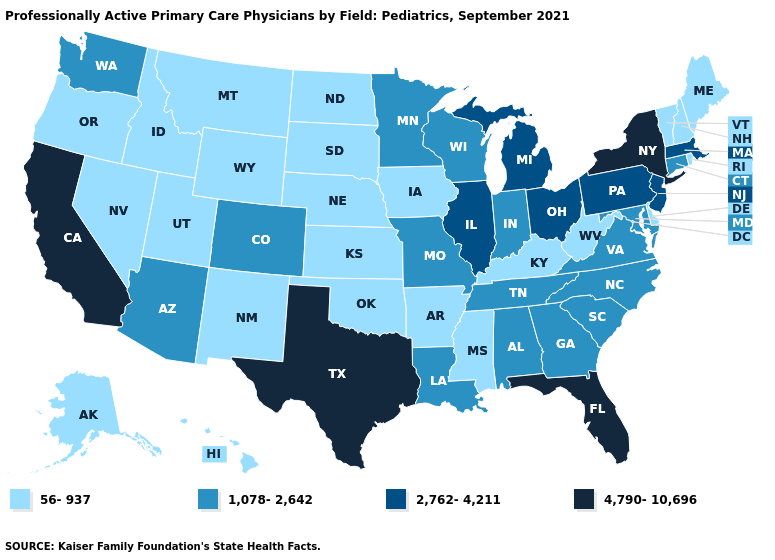What is the value of Kentucky?
Concise answer only. 56-937. How many symbols are there in the legend?
Keep it brief. 4. What is the value of Iowa?
Keep it brief. 56-937. Does Michigan have a lower value than New York?
Short answer required. Yes. What is the value of Massachusetts?
Short answer required. 2,762-4,211. What is the lowest value in the USA?
Keep it brief. 56-937. Does California have the highest value in the USA?
Short answer required. Yes. Name the states that have a value in the range 56-937?
Keep it brief. Alaska, Arkansas, Delaware, Hawaii, Idaho, Iowa, Kansas, Kentucky, Maine, Mississippi, Montana, Nebraska, Nevada, New Hampshire, New Mexico, North Dakota, Oklahoma, Oregon, Rhode Island, South Dakota, Utah, Vermont, West Virginia, Wyoming. Does South Carolina have the highest value in the USA?
Quick response, please. No. Name the states that have a value in the range 56-937?
Answer briefly. Alaska, Arkansas, Delaware, Hawaii, Idaho, Iowa, Kansas, Kentucky, Maine, Mississippi, Montana, Nebraska, Nevada, New Hampshire, New Mexico, North Dakota, Oklahoma, Oregon, Rhode Island, South Dakota, Utah, Vermont, West Virginia, Wyoming. What is the value of Oklahoma?
Answer briefly. 56-937. What is the highest value in the South ?
Be succinct. 4,790-10,696. Does Massachusetts have the same value as Nebraska?
Be succinct. No. Does Iowa have the lowest value in the MidWest?
Give a very brief answer. Yes. Among the states that border Missouri , which have the lowest value?
Keep it brief. Arkansas, Iowa, Kansas, Kentucky, Nebraska, Oklahoma. 